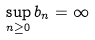Convert formula to latex. <formula><loc_0><loc_0><loc_500><loc_500>\sup _ { n \geq 0 } b _ { n } = \infty</formula> 